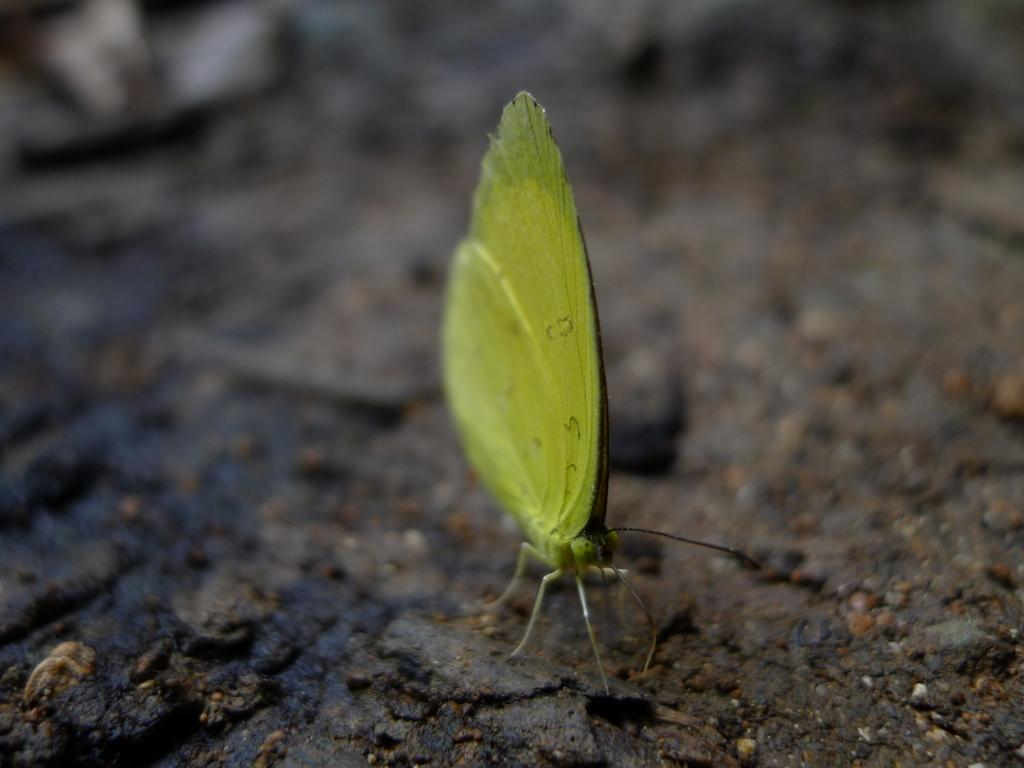What type of creature is featured in the image? There is a butterfly depicted in the image. What type of tub is visible in the image? There is no tub present in the image; it only features a butterfly. 